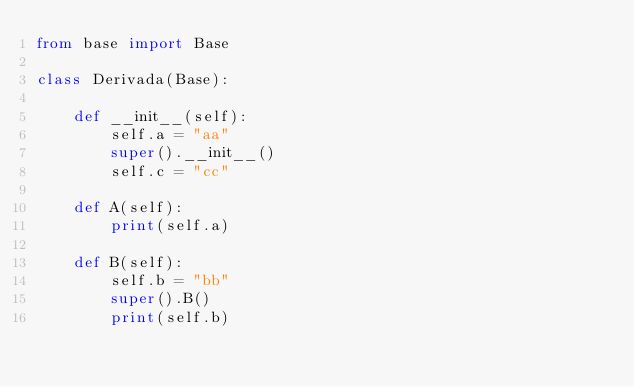Convert code to text. <code><loc_0><loc_0><loc_500><loc_500><_Python_>from base import Base

class Derivada(Base): 
 
    def __init__(self): 
        self.a = "aa" 
        super().__init__() 
        self.c = "cc" 
 
    def A(self): 
        print(self.a) 
 
    def B(self): 
        self.b = "bb" 
        super().B() 
        print(self.b) 
 </code> 